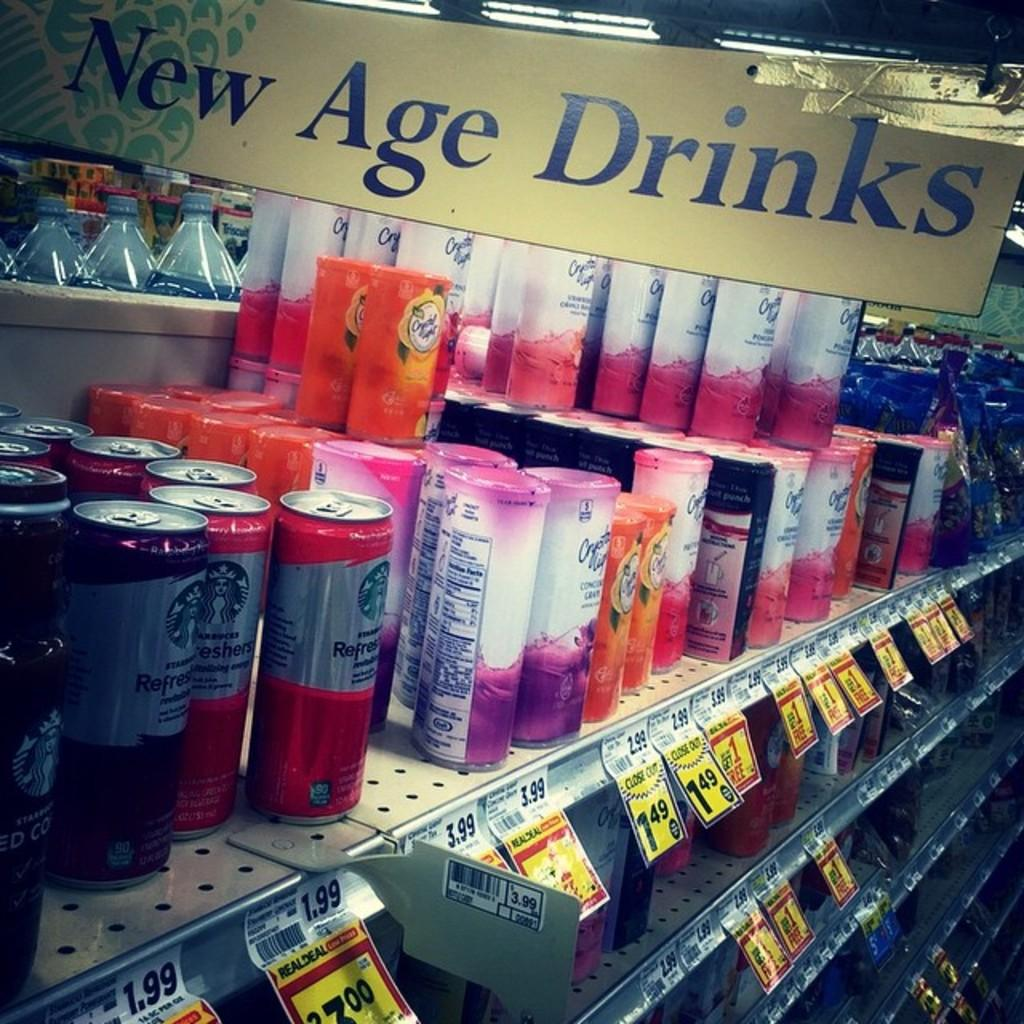<image>
Present a compact description of the photo's key features. A store has a display of New Age Drinks for sale. 